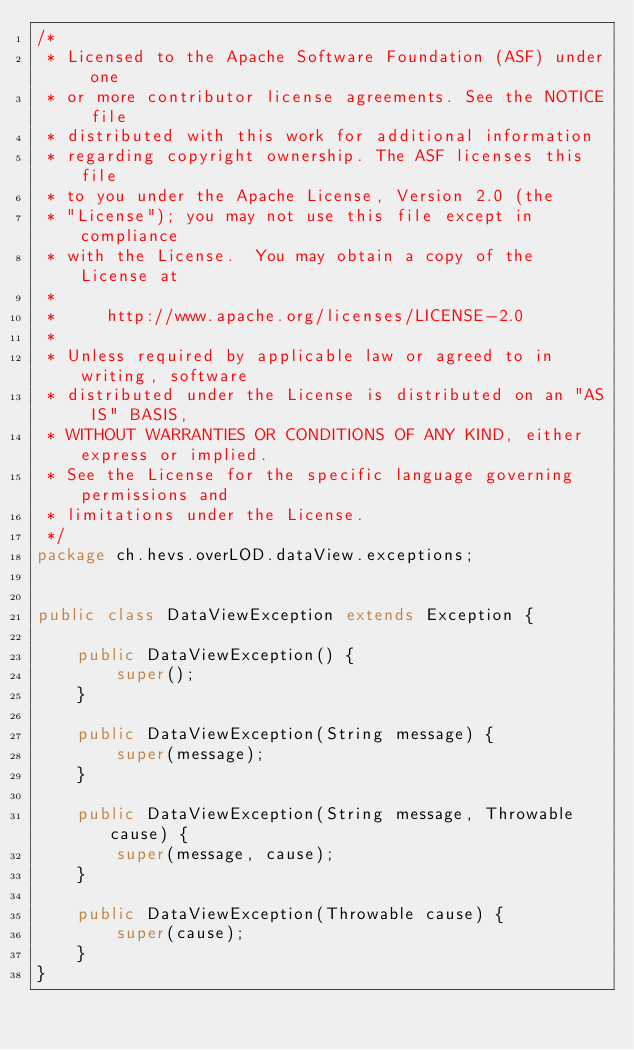<code> <loc_0><loc_0><loc_500><loc_500><_Java_>/*
 * Licensed to the Apache Software Foundation (ASF) under one
 * or more contributor license agreements. See the NOTICE file
 * distributed with this work for additional information
 * regarding copyright ownership. The ASF licenses this file
 * to you under the Apache License, Version 2.0 (the
 * "License"); you may not use this file except in compliance
 * with the License.  You may obtain a copy of the License at
 *
 *     http://www.apache.org/licenses/LICENSE-2.0
 *
 * Unless required by applicable law or agreed to in writing, software
 * distributed under the License is distributed on an "AS IS" BASIS,
 * WITHOUT WARRANTIES OR CONDITIONS OF ANY KIND, either express or implied.
 * See the License for the specific language governing permissions and
 * limitations under the License.
 */
package ch.hevs.overLOD.dataView.exceptions;


public class DataViewException extends Exception {

    public DataViewException() {
        super();
    }

    public DataViewException(String message) {
        super(message);
    }

    public DataViewException(String message, Throwable cause) {
        super(message, cause);
    }

    public DataViewException(Throwable cause) {
        super(cause);
    }
}</code> 